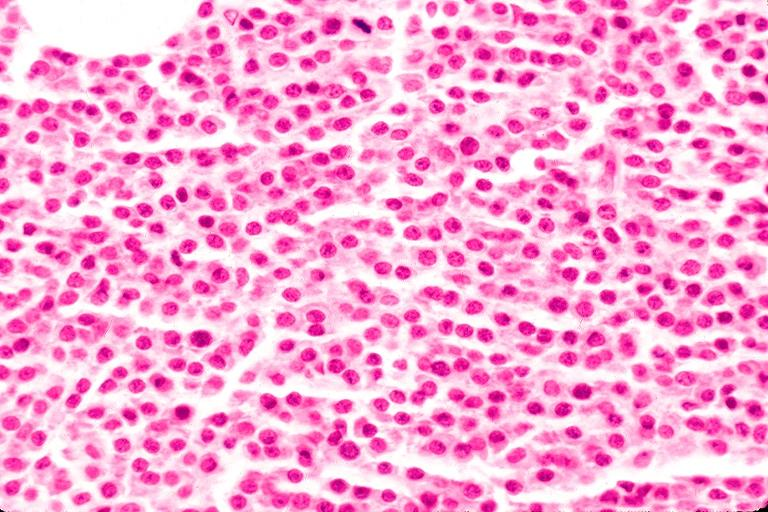what is present?
Answer the question using a single word or phrase. Oral 